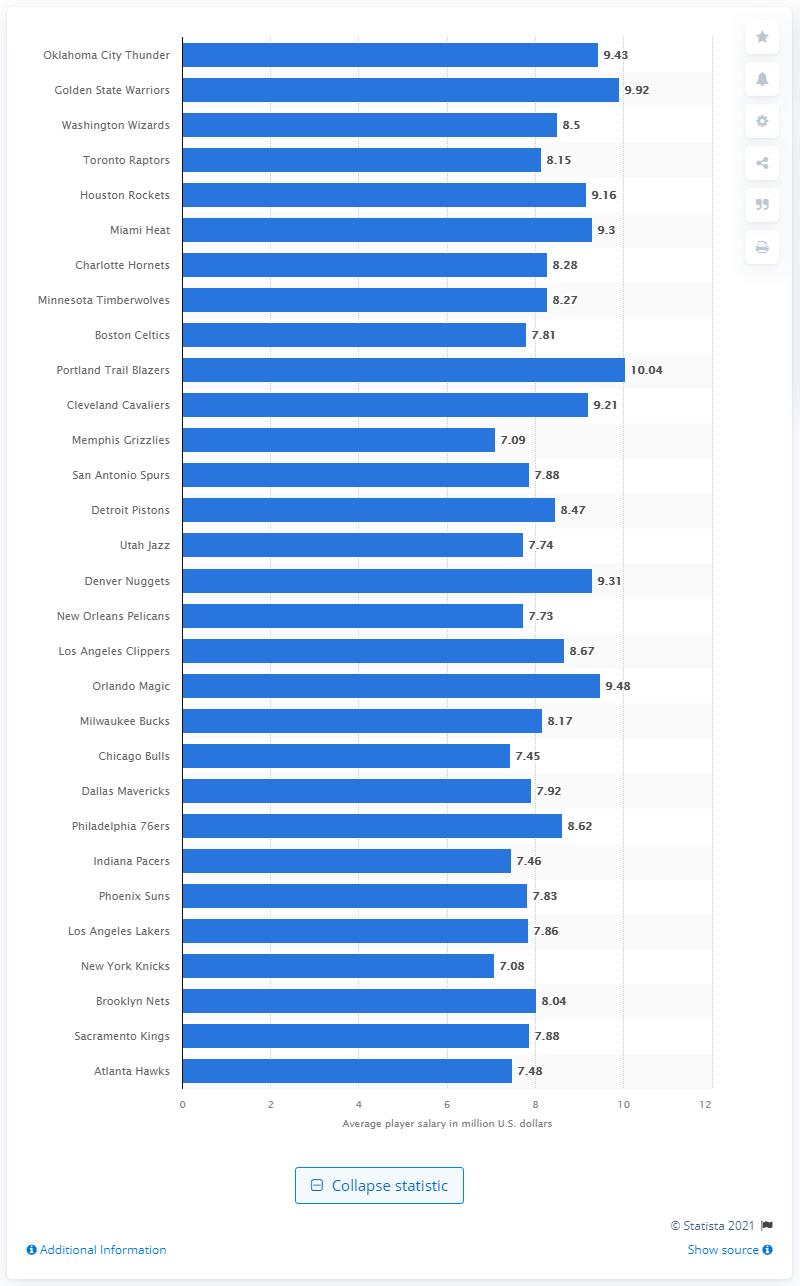Outline some significant characteristics in this image. In the 2019/2020 season, the Portland Trail Blazers' average player salary was 10.04. 